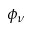Convert formula to latex. <formula><loc_0><loc_0><loc_500><loc_500>\phi _ { \nu }</formula> 